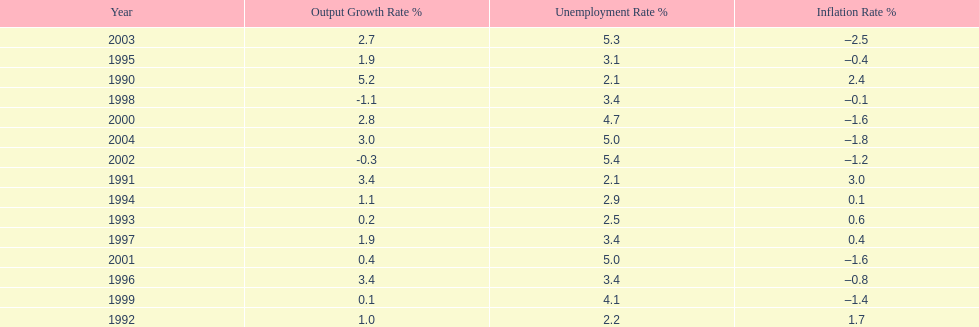Were the highest unemployment rates in japan before or after the year 2000? After. 